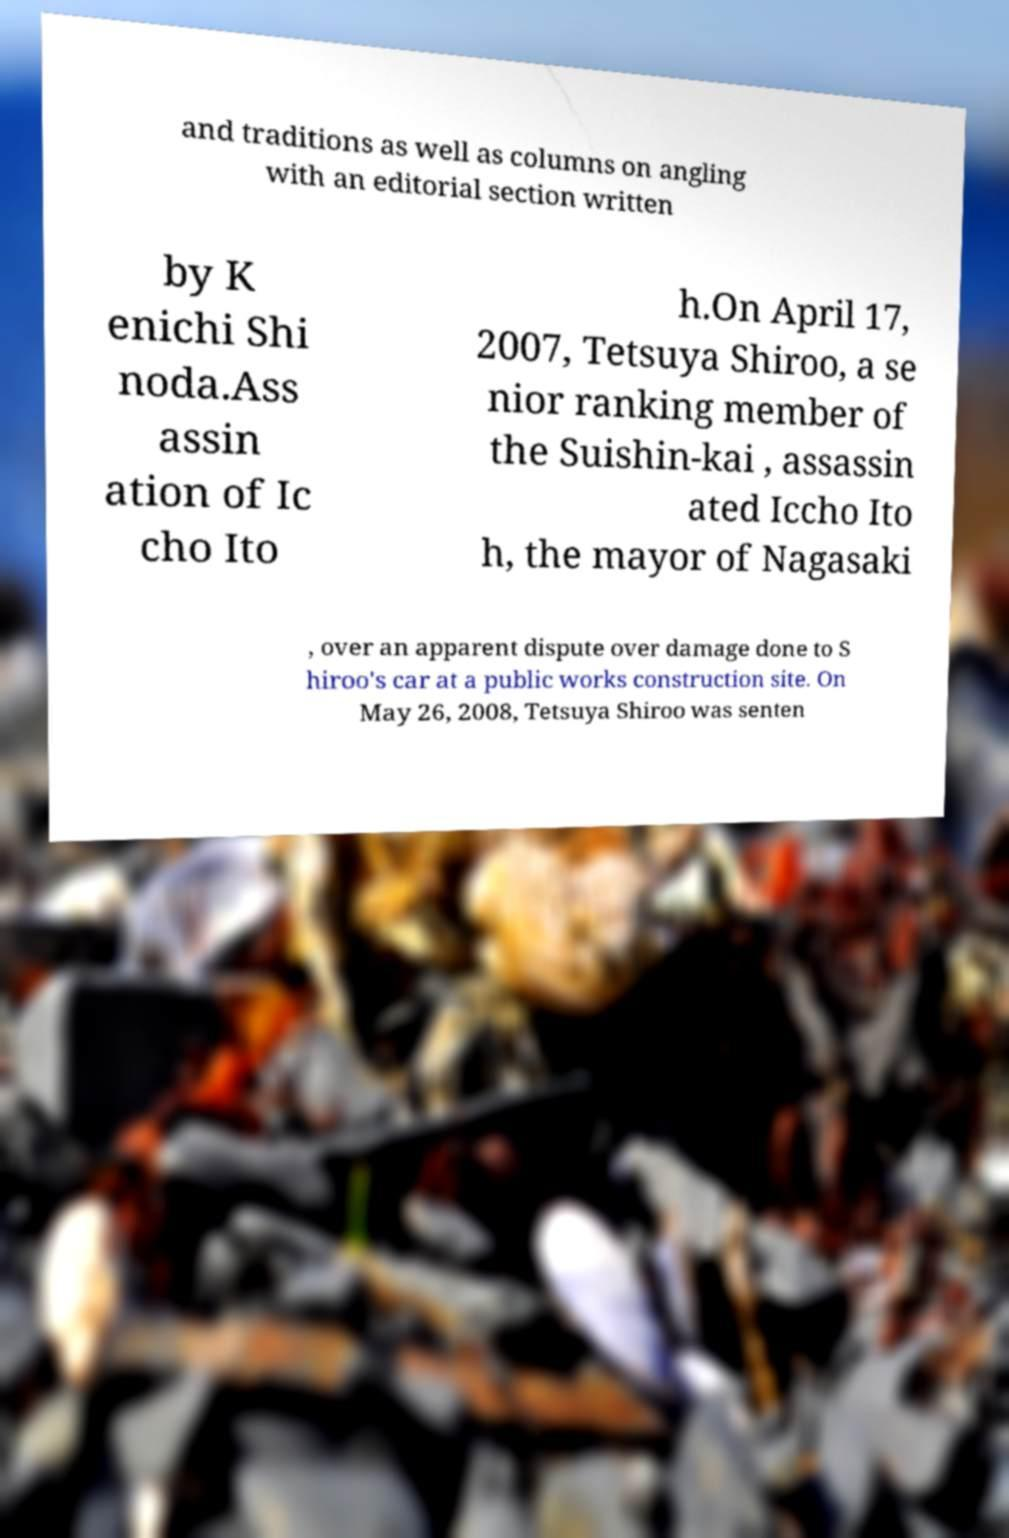Can you accurately transcribe the text from the provided image for me? and traditions as well as columns on angling with an editorial section written by K enichi Shi noda.Ass assin ation of Ic cho Ito h.On April 17, 2007, Tetsuya Shiroo, a se nior ranking member of the Suishin-kai , assassin ated Iccho Ito h, the mayor of Nagasaki , over an apparent dispute over damage done to S hiroo's car at a public works construction site. On May 26, 2008, Tetsuya Shiroo was senten 